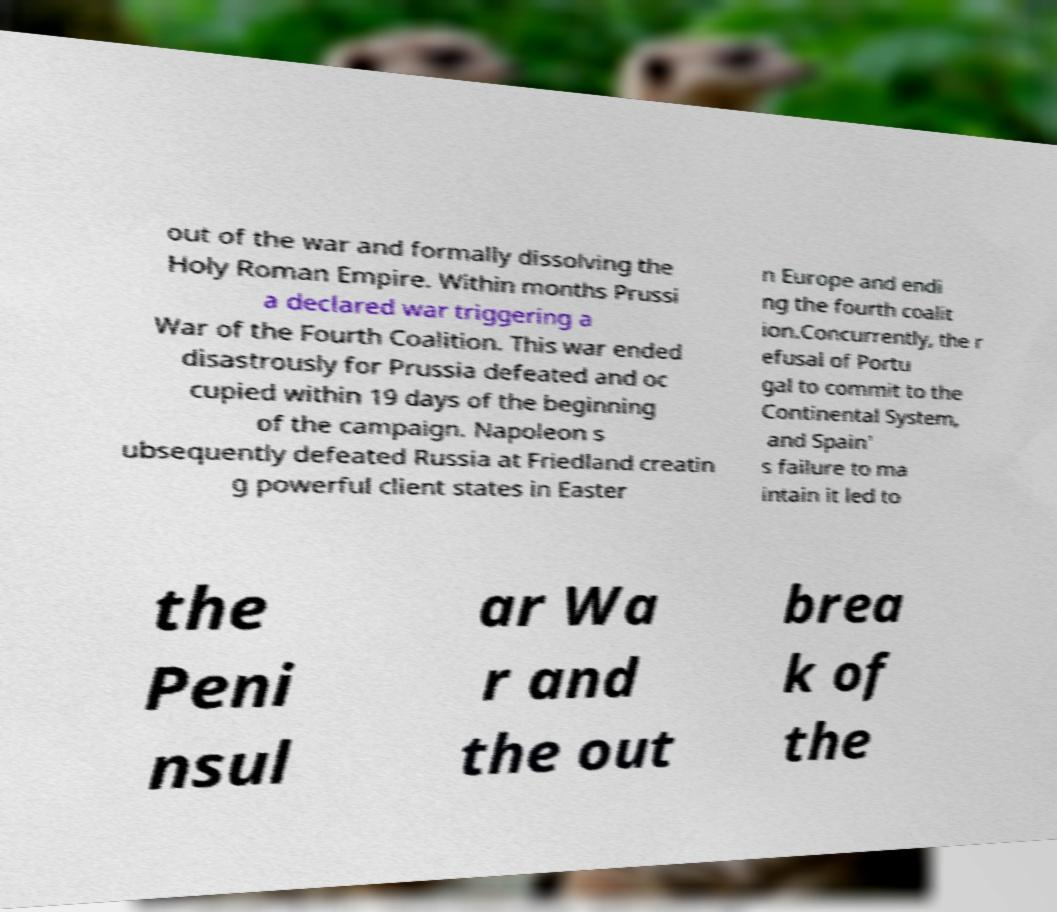What messages or text are displayed in this image? I need them in a readable, typed format. out of the war and formally dissolving the Holy Roman Empire. Within months Prussi a declared war triggering a War of the Fourth Coalition. This war ended disastrously for Prussia defeated and oc cupied within 19 days of the beginning of the campaign. Napoleon s ubsequently defeated Russia at Friedland creatin g powerful client states in Easter n Europe and endi ng the fourth coalit ion.Concurrently, the r efusal of Portu gal to commit to the Continental System, and Spain' s failure to ma intain it led to the Peni nsul ar Wa r and the out brea k of the 